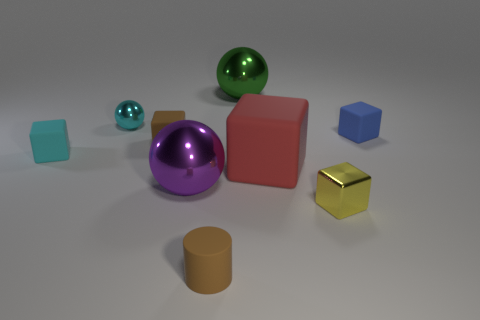Subtract 1 cubes. How many cubes are left? 4 Subtract all yellow blocks. How many blocks are left? 4 Subtract all tiny metal blocks. How many blocks are left? 4 Subtract all blue cubes. Subtract all yellow spheres. How many cubes are left? 4 Add 1 big metallic objects. How many objects exist? 10 Subtract all spheres. How many objects are left? 6 Subtract 1 purple spheres. How many objects are left? 8 Subtract all tiny cubes. Subtract all blue rubber things. How many objects are left? 4 Add 5 tiny metal blocks. How many tiny metal blocks are left? 6 Add 9 green things. How many green things exist? 10 